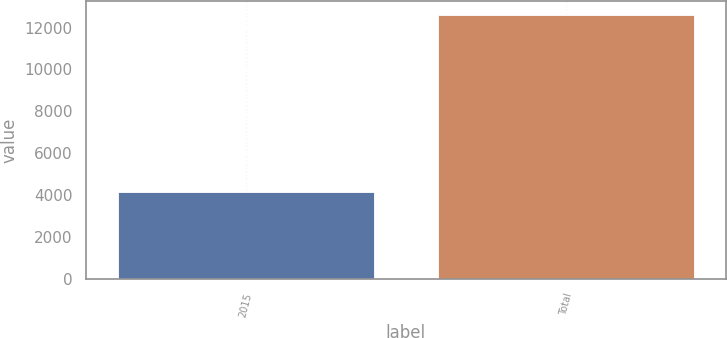Convert chart. <chart><loc_0><loc_0><loc_500><loc_500><bar_chart><fcel>2015<fcel>Total<nl><fcel>4157<fcel>12626<nl></chart> 